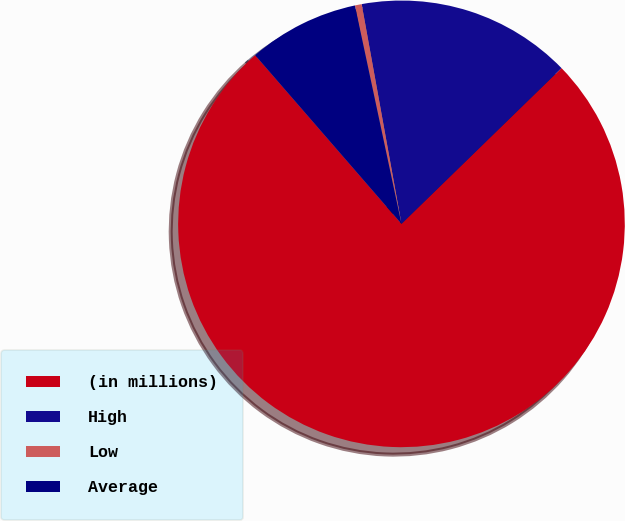<chart> <loc_0><loc_0><loc_500><loc_500><pie_chart><fcel>(in millions)<fcel>High<fcel>Low<fcel>Average<nl><fcel>75.91%<fcel>15.57%<fcel>0.49%<fcel>8.03%<nl></chart> 